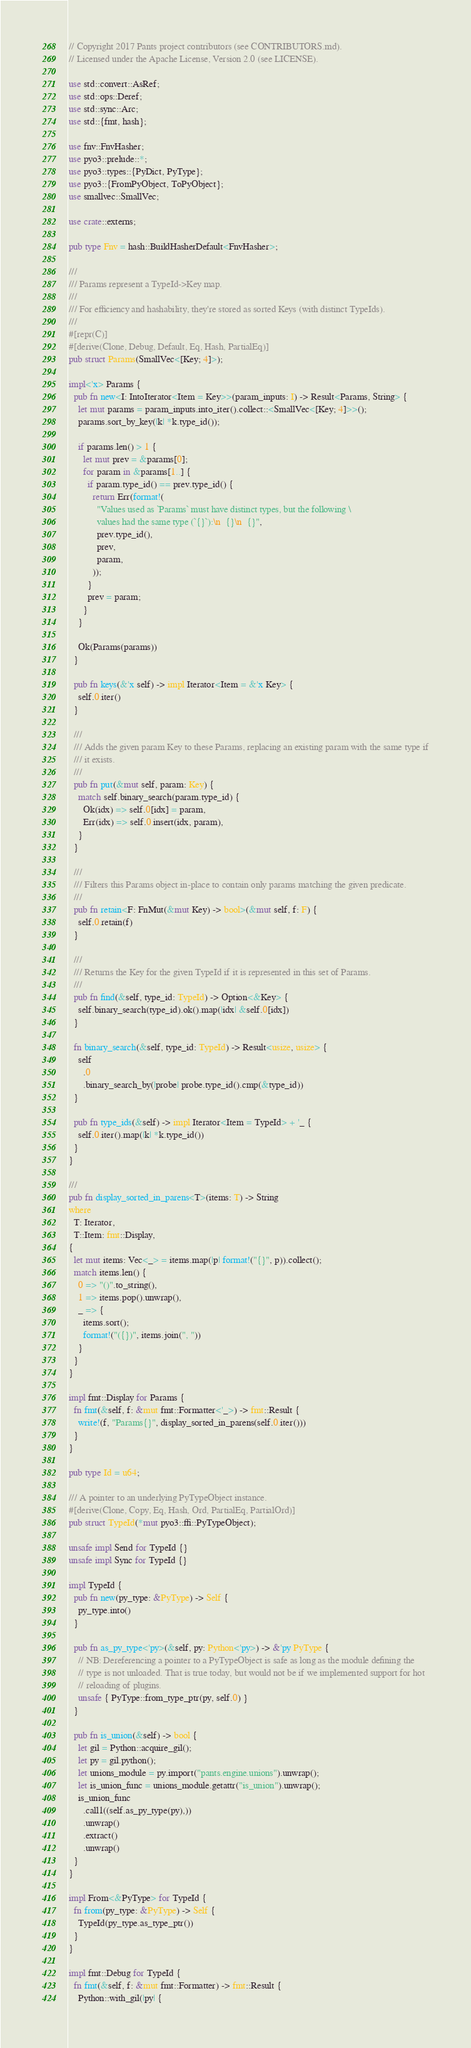Convert code to text. <code><loc_0><loc_0><loc_500><loc_500><_Rust_>// Copyright 2017 Pants project contributors (see CONTRIBUTORS.md).
// Licensed under the Apache License, Version 2.0 (see LICENSE).

use std::convert::AsRef;
use std::ops::Deref;
use std::sync::Arc;
use std::{fmt, hash};

use fnv::FnvHasher;
use pyo3::prelude::*;
use pyo3::types::{PyDict, PyType};
use pyo3::{FromPyObject, ToPyObject};
use smallvec::SmallVec;

use crate::externs;

pub type Fnv = hash::BuildHasherDefault<FnvHasher>;

///
/// Params represent a TypeId->Key map.
///
/// For efficiency and hashability, they're stored as sorted Keys (with distinct TypeIds).
///
#[repr(C)]
#[derive(Clone, Debug, Default, Eq, Hash, PartialEq)]
pub struct Params(SmallVec<[Key; 4]>);

impl<'x> Params {
  pub fn new<I: IntoIterator<Item = Key>>(param_inputs: I) -> Result<Params, String> {
    let mut params = param_inputs.into_iter().collect::<SmallVec<[Key; 4]>>();
    params.sort_by_key(|k| *k.type_id());

    if params.len() > 1 {
      let mut prev = &params[0];
      for param in &params[1..] {
        if param.type_id() == prev.type_id() {
          return Err(format!(
            "Values used as `Params` must have distinct types, but the following \
            values had the same type (`{}`):\n  {}\n  {}",
            prev.type_id(),
            prev,
            param,
          ));
        }
        prev = param;
      }
    }

    Ok(Params(params))
  }

  pub fn keys(&'x self) -> impl Iterator<Item = &'x Key> {
    self.0.iter()
  }

  ///
  /// Adds the given param Key to these Params, replacing an existing param with the same type if
  /// it exists.
  ///
  pub fn put(&mut self, param: Key) {
    match self.binary_search(param.type_id) {
      Ok(idx) => self.0[idx] = param,
      Err(idx) => self.0.insert(idx, param),
    }
  }

  ///
  /// Filters this Params object in-place to contain only params matching the given predicate.
  ///
  pub fn retain<F: FnMut(&mut Key) -> bool>(&mut self, f: F) {
    self.0.retain(f)
  }

  ///
  /// Returns the Key for the given TypeId if it is represented in this set of Params.
  ///
  pub fn find(&self, type_id: TypeId) -> Option<&Key> {
    self.binary_search(type_id).ok().map(|idx| &self.0[idx])
  }

  fn binary_search(&self, type_id: TypeId) -> Result<usize, usize> {
    self
      .0
      .binary_search_by(|probe| probe.type_id().cmp(&type_id))
  }

  pub fn type_ids(&self) -> impl Iterator<Item = TypeId> + '_ {
    self.0.iter().map(|k| *k.type_id())
  }
}

///
pub fn display_sorted_in_parens<T>(items: T) -> String
where
  T: Iterator,
  T::Item: fmt::Display,
{
  let mut items: Vec<_> = items.map(|p| format!("{}", p)).collect();
  match items.len() {
    0 => "()".to_string(),
    1 => items.pop().unwrap(),
    _ => {
      items.sort();
      format!("({})", items.join(", "))
    }
  }
}

impl fmt::Display for Params {
  fn fmt(&self, f: &mut fmt::Formatter<'_>) -> fmt::Result {
    write!(f, "Params{}", display_sorted_in_parens(self.0.iter()))
  }
}

pub type Id = u64;

/// A pointer to an underlying PyTypeObject instance.
#[derive(Clone, Copy, Eq, Hash, Ord, PartialEq, PartialOrd)]
pub struct TypeId(*mut pyo3::ffi::PyTypeObject);

unsafe impl Send for TypeId {}
unsafe impl Sync for TypeId {}

impl TypeId {
  pub fn new(py_type: &PyType) -> Self {
    py_type.into()
  }

  pub fn as_py_type<'py>(&self, py: Python<'py>) -> &'py PyType {
    // NB: Dereferencing a pointer to a PyTypeObject is safe as long as the module defining the
    // type is not unloaded. That is true today, but would not be if we implemented support for hot
    // reloading of plugins.
    unsafe { PyType::from_type_ptr(py, self.0) }
  }

  pub fn is_union(&self) -> bool {
    let gil = Python::acquire_gil();
    let py = gil.python();
    let unions_module = py.import("pants.engine.unions").unwrap();
    let is_union_func = unions_module.getattr("is_union").unwrap();
    is_union_func
      .call1((self.as_py_type(py),))
      .unwrap()
      .extract()
      .unwrap()
  }
}

impl From<&PyType> for TypeId {
  fn from(py_type: &PyType) -> Self {
    TypeId(py_type.as_type_ptr())
  }
}

impl fmt::Debug for TypeId {
  fn fmt(&self, f: &mut fmt::Formatter) -> fmt::Result {
    Python::with_gil(|py| {</code> 